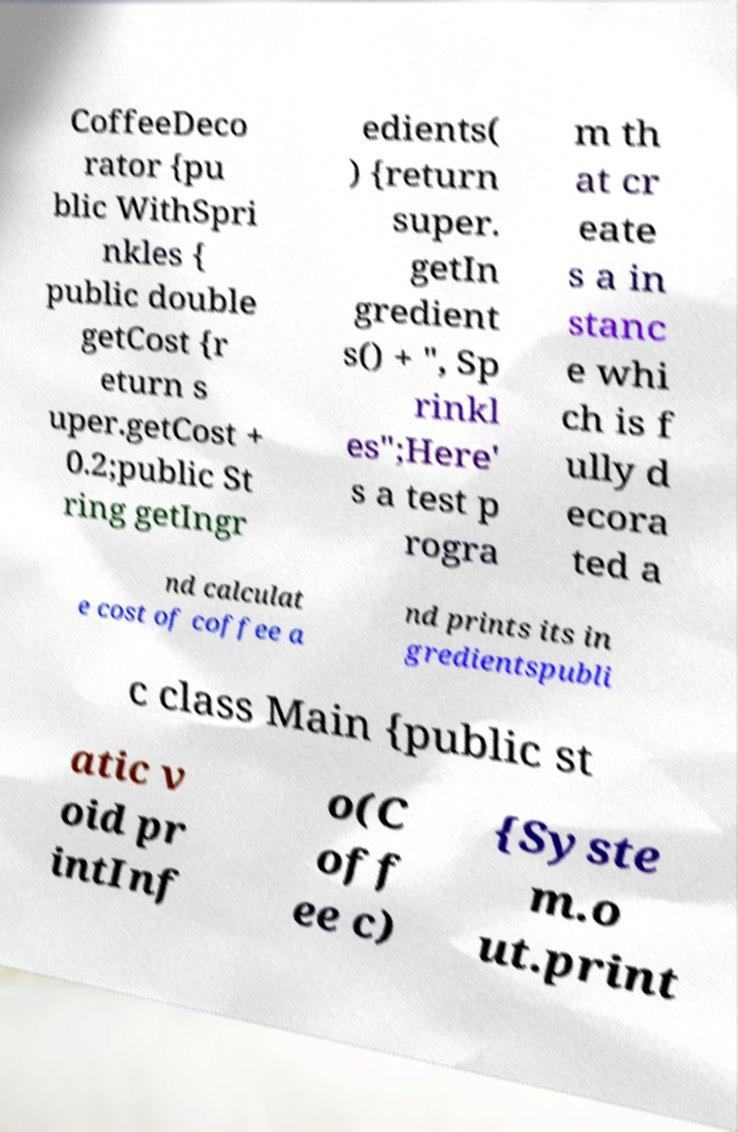Could you assist in decoding the text presented in this image and type it out clearly? CoffeeDeco rator {pu blic WithSpri nkles { public double getCost {r eturn s uper.getCost + 0.2;public St ring getIngr edients( ) {return super. getIn gredient s() + ", Sp rinkl es";Here' s a test p rogra m th at cr eate s a in stanc e whi ch is f ully d ecora ted a nd calculat e cost of coffee a nd prints its in gredientspubli c class Main {public st atic v oid pr intInf o(C off ee c) {Syste m.o ut.print 